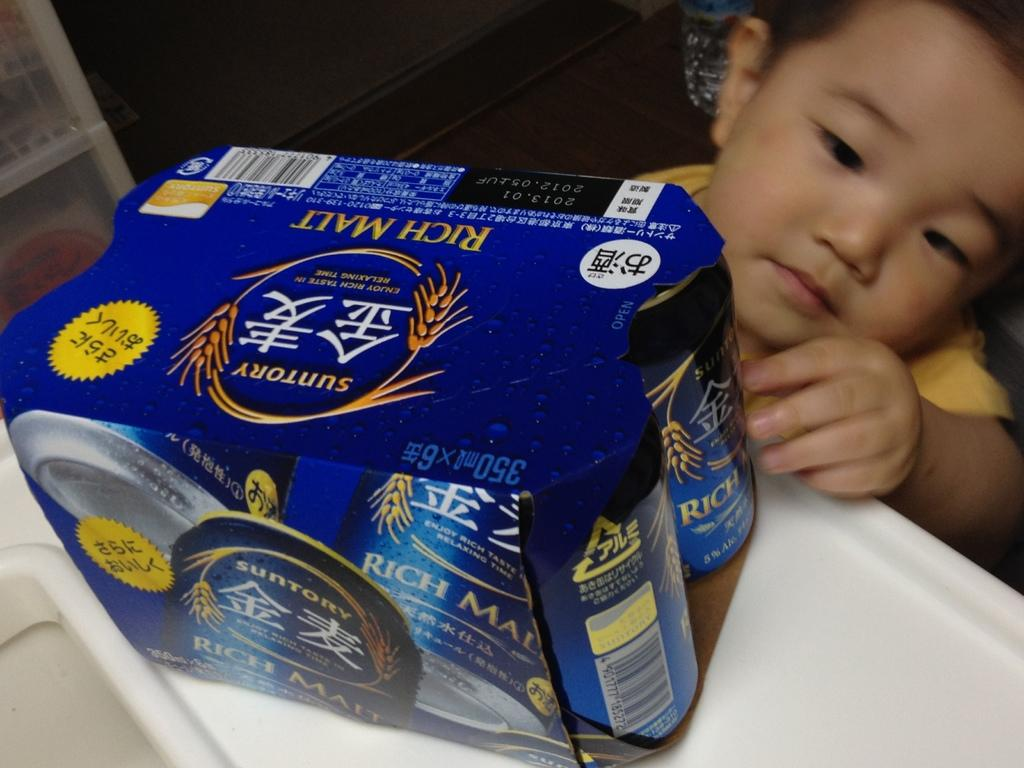Who is the main subject in the image? There is a boy in the image. What is the boy wearing? The boy is wearing a yellow shirt. What piece of furniture is present in the image? There is a table in the image. What object can be seen on the table? There is a box on the table. What is the plot of the story unfolding in the image? There is no story or plot depicted in the image; it simply shows a boy wearing a yellow shirt, a table, and a box on the table. 